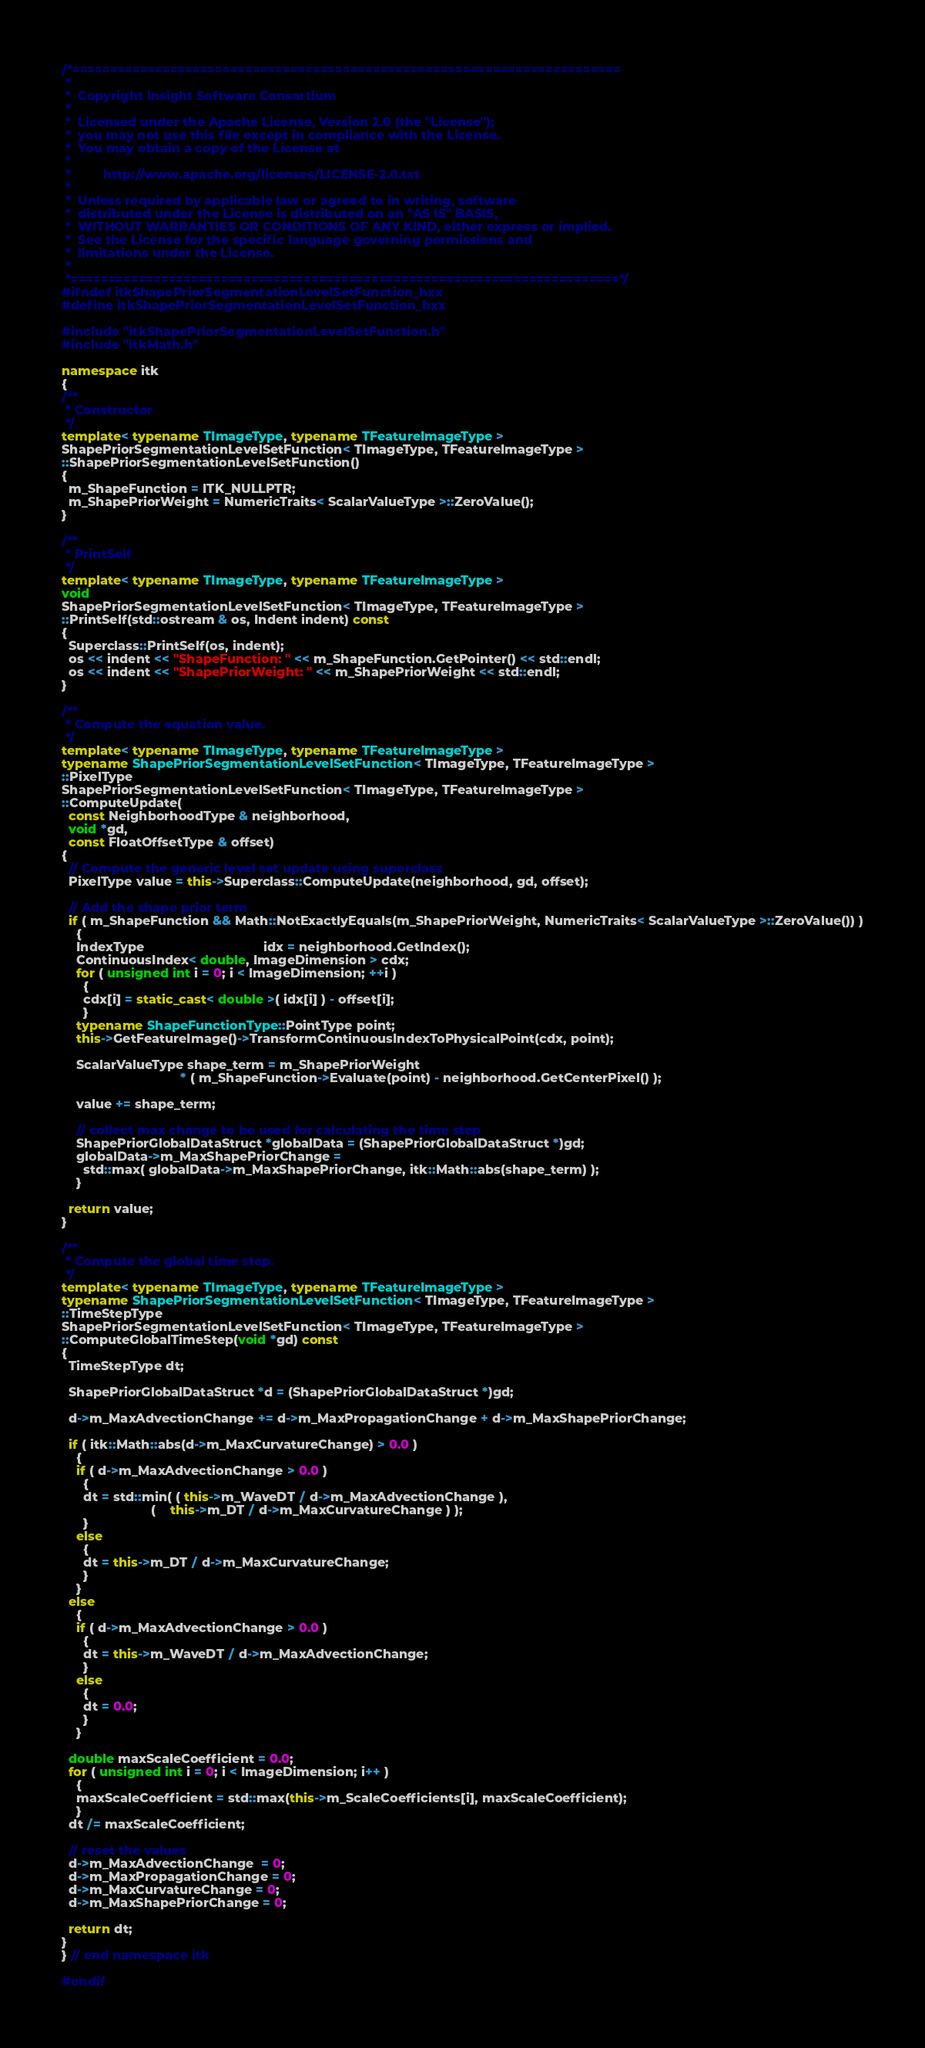Convert code to text. <code><loc_0><loc_0><loc_500><loc_500><_C++_>/*=========================================================================
 *
 *  Copyright Insight Software Consortium
 *
 *  Licensed under the Apache License, Version 2.0 (the "License");
 *  you may not use this file except in compliance with the License.
 *  You may obtain a copy of the License at
 *
 *         http://www.apache.org/licenses/LICENSE-2.0.txt
 *
 *  Unless required by applicable law or agreed to in writing, software
 *  distributed under the License is distributed on an "AS IS" BASIS,
 *  WITHOUT WARRANTIES OR CONDITIONS OF ANY KIND, either express or implied.
 *  See the License for the specific language governing permissions and
 *  limitations under the License.
 *
 *=========================================================================*/
#ifndef itkShapePriorSegmentationLevelSetFunction_hxx
#define itkShapePriorSegmentationLevelSetFunction_hxx

#include "itkShapePriorSegmentationLevelSetFunction.h"
#include "itkMath.h"

namespace itk
{
/**
 * Constructor
 */
template< typename TImageType, typename TFeatureImageType >
ShapePriorSegmentationLevelSetFunction< TImageType, TFeatureImageType >
::ShapePriorSegmentationLevelSetFunction()
{
  m_ShapeFunction = ITK_NULLPTR;
  m_ShapePriorWeight = NumericTraits< ScalarValueType >::ZeroValue();
}

/**
 * PrintSelf
 */
template< typename TImageType, typename TFeatureImageType >
void
ShapePriorSegmentationLevelSetFunction< TImageType, TFeatureImageType >
::PrintSelf(std::ostream & os, Indent indent) const
{
  Superclass::PrintSelf(os, indent);
  os << indent << "ShapeFunction: " << m_ShapeFunction.GetPointer() << std::endl;
  os << indent << "ShapePriorWeight: " << m_ShapePriorWeight << std::endl;
}

/**
 * Compute the equation value.
 */
template< typename TImageType, typename TFeatureImageType >
typename ShapePriorSegmentationLevelSetFunction< TImageType, TFeatureImageType >
::PixelType
ShapePriorSegmentationLevelSetFunction< TImageType, TFeatureImageType >
::ComputeUpdate(
  const NeighborhoodType & neighborhood,
  void *gd,
  const FloatOffsetType & offset)
{
  // Compute the generic level set update using superclass
  PixelType value = this->Superclass::ComputeUpdate(neighborhood, gd, offset);

  // Add the shape prior term
  if ( m_ShapeFunction && Math::NotExactlyEquals(m_ShapePriorWeight, NumericTraits< ScalarValueType >::ZeroValue()) )
    {
    IndexType                                 idx = neighborhood.GetIndex();
    ContinuousIndex< double, ImageDimension > cdx;
    for ( unsigned int i = 0; i < ImageDimension; ++i )
      {
      cdx[i] = static_cast< double >( idx[i] ) - offset[i];
      }
    typename ShapeFunctionType::PointType point;
    this->GetFeatureImage()->TransformContinuousIndexToPhysicalPoint(cdx, point);

    ScalarValueType shape_term = m_ShapePriorWeight
                                 * ( m_ShapeFunction->Evaluate(point) - neighborhood.GetCenterPixel() );

    value += shape_term;

    // collect max change to be used for calculating the time step
    ShapePriorGlobalDataStruct *globalData = (ShapePriorGlobalDataStruct *)gd;
    globalData->m_MaxShapePriorChange =
      std::max( globalData->m_MaxShapePriorChange, itk::Math::abs(shape_term) );
    }

  return value;
}

/**
 * Compute the global time step.
 */
template< typename TImageType, typename TFeatureImageType >
typename ShapePriorSegmentationLevelSetFunction< TImageType, TFeatureImageType >
::TimeStepType
ShapePriorSegmentationLevelSetFunction< TImageType, TFeatureImageType >
::ComputeGlobalTimeStep(void *gd) const
{
  TimeStepType dt;

  ShapePriorGlobalDataStruct *d = (ShapePriorGlobalDataStruct *)gd;

  d->m_MaxAdvectionChange += d->m_MaxPropagationChange + d->m_MaxShapePriorChange;

  if ( itk::Math::abs(d->m_MaxCurvatureChange) > 0.0 )
    {
    if ( d->m_MaxAdvectionChange > 0.0 )
      {
      dt = std::min( ( this->m_WaveDT / d->m_MaxAdvectionChange ),
                         (    this->m_DT / d->m_MaxCurvatureChange ) );
      }
    else
      {
      dt = this->m_DT / d->m_MaxCurvatureChange;
      }
    }
  else
    {
    if ( d->m_MaxAdvectionChange > 0.0 )
      {
      dt = this->m_WaveDT / d->m_MaxAdvectionChange;
      }
    else
      {
      dt = 0.0;
      }
    }

  double maxScaleCoefficient = 0.0;
  for ( unsigned int i = 0; i < ImageDimension; i++ )
    {
    maxScaleCoefficient = std::max(this->m_ScaleCoefficients[i], maxScaleCoefficient);
    }
  dt /= maxScaleCoefficient;

  // reset the values
  d->m_MaxAdvectionChange  = 0;
  d->m_MaxPropagationChange = 0;
  d->m_MaxCurvatureChange = 0;
  d->m_MaxShapePriorChange = 0;

  return dt;
}
} // end namespace itk

#endif
</code> 